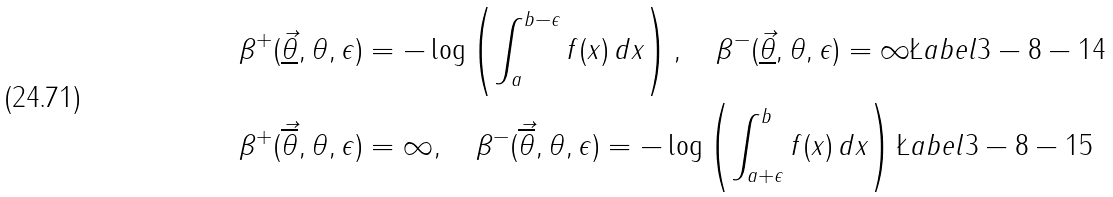Convert formula to latex. <formula><loc_0><loc_0><loc_500><loc_500>\beta ^ { + } ( \vec { \underline { \theta } } , \theta , \epsilon ) & = - \log \left ( \int _ { a } ^ { b - \epsilon } f ( x ) \, d x \right ) , \quad \beta ^ { - } ( \vec { \underline { \theta } } , \theta , \epsilon ) = \infty \L a b e l { 3 - 8 - 1 4 } \\ \beta ^ { + } ( \vec { \overline { \theta } } , \theta , \epsilon ) & = \infty , \quad \beta ^ { - } ( \vec { \overline { \theta } } , \theta , \epsilon ) = - \log \left ( \int _ { a + \epsilon } ^ { b } f ( x ) \, d x \right ) \L a b e l { 3 - 8 - 1 5 }</formula> 